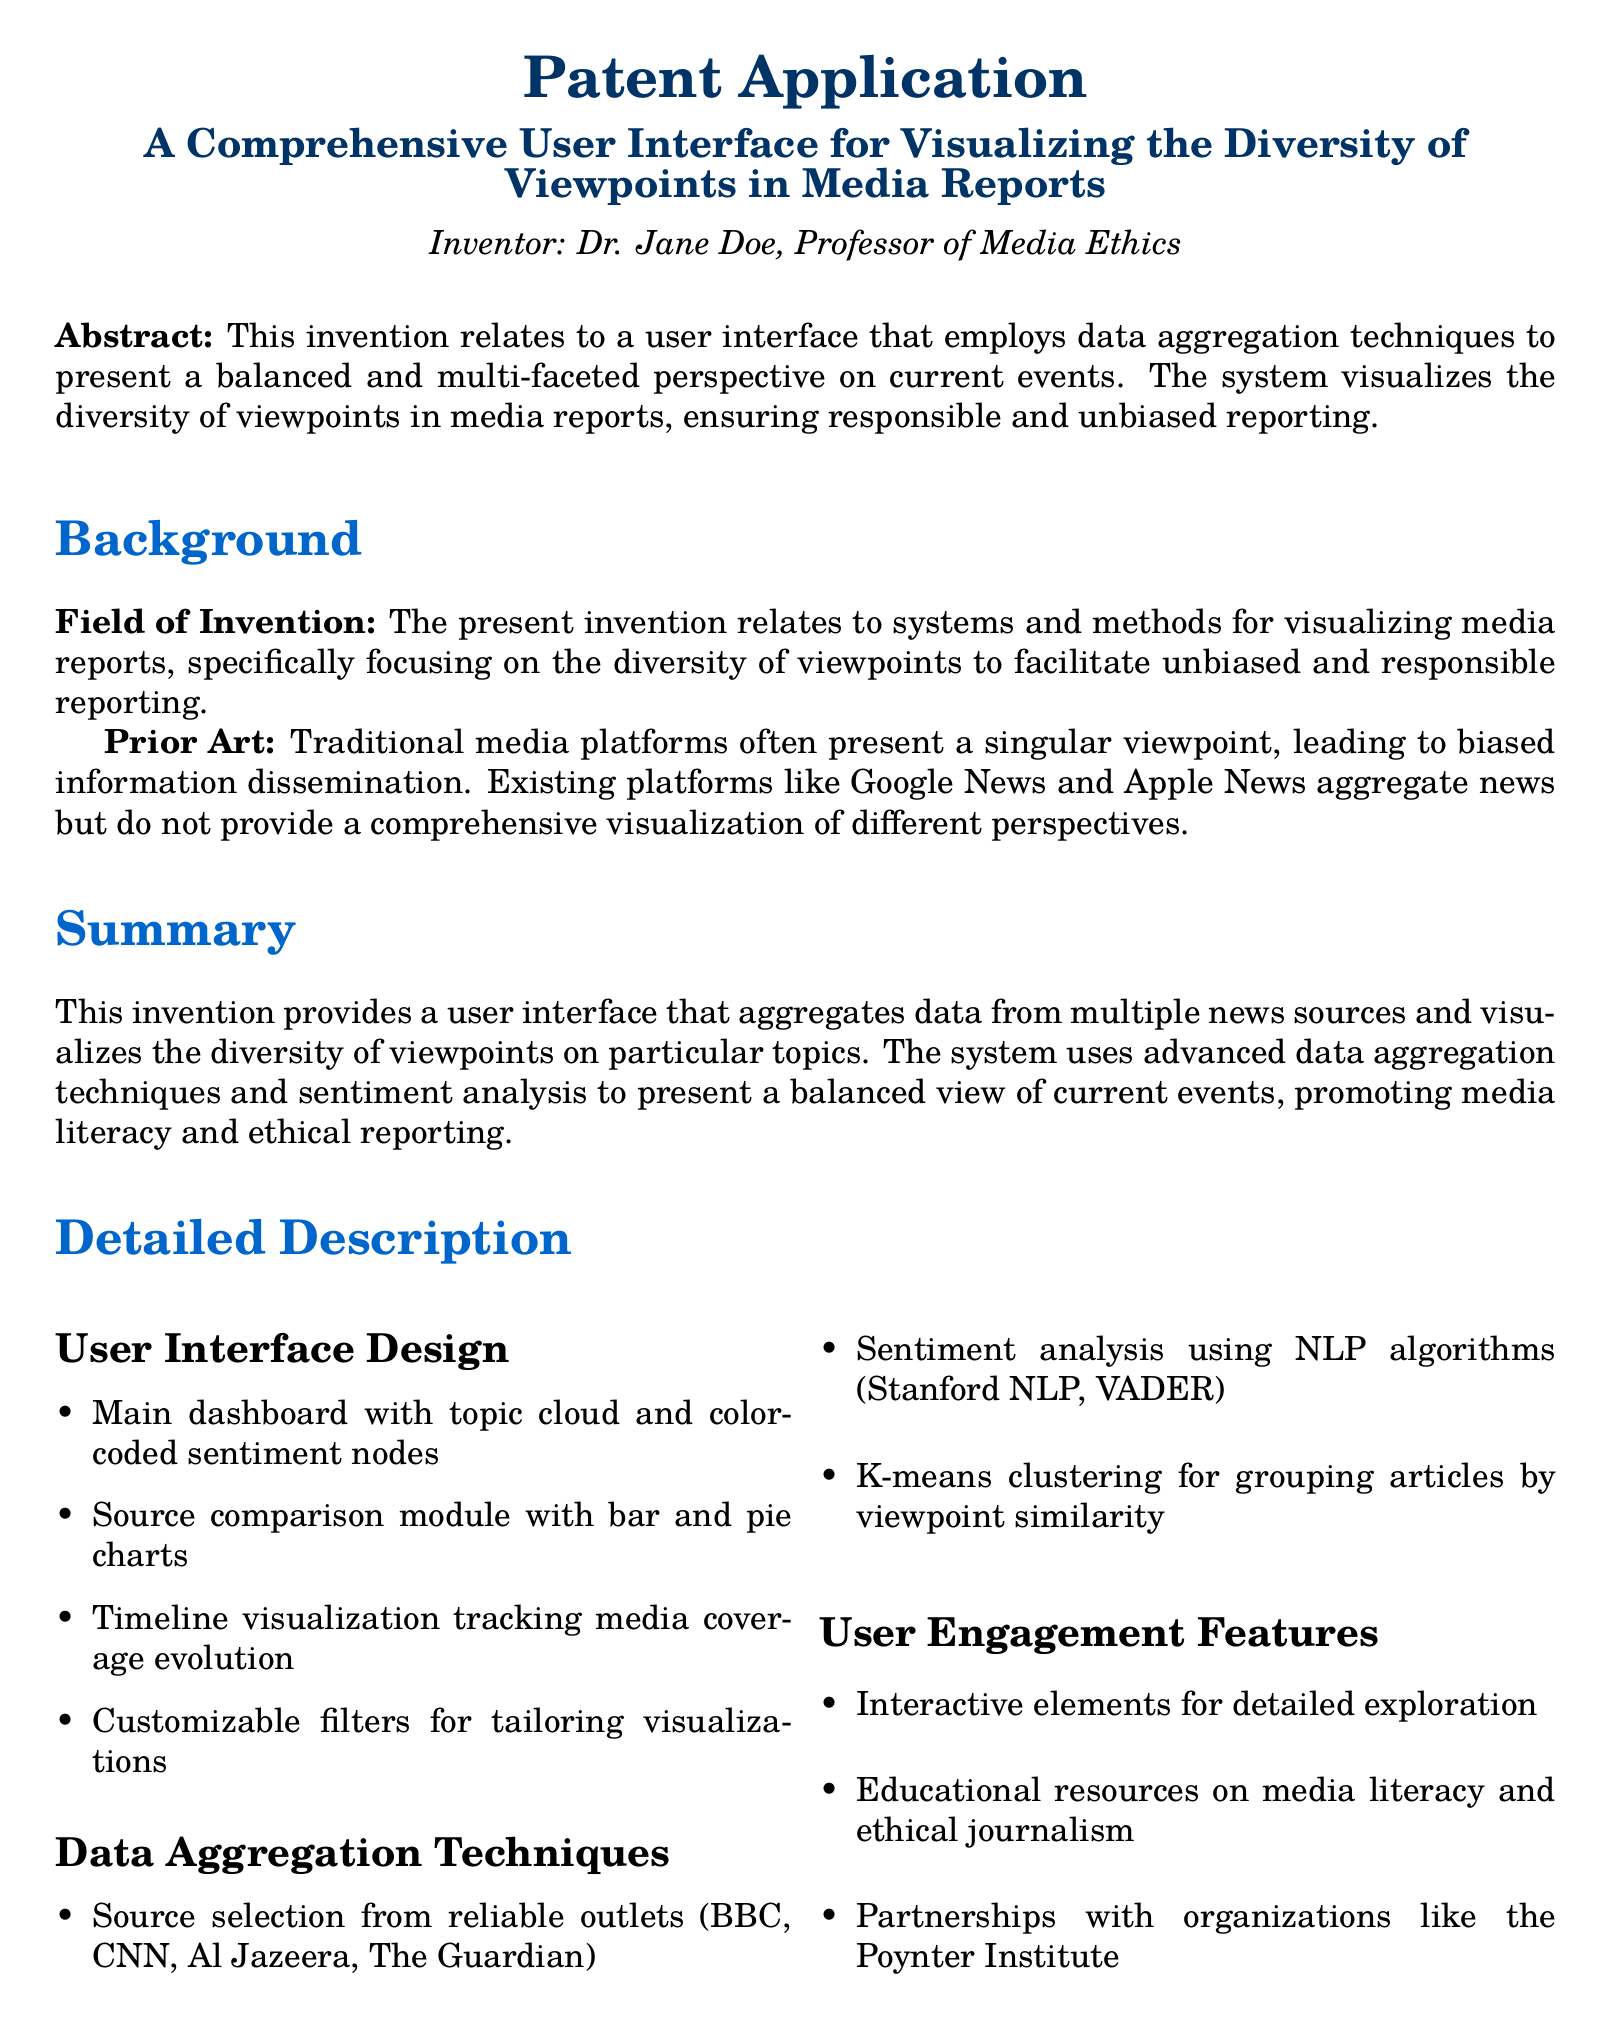What is the title of the patent application? The title is explicitly mentioned in the document under the heading.
Answer: A Comprehensive User Interface for Visualizing the Diversity of Viewpoints in Media Reports Who is the inventor of the user interface? The document attributes the invention to a specific individual in the author section.
Answer: Dr. Jane Doe What is the primary field of invention? The field of invention is identified in the background section of the document.
Answer: Visualizing media reports Which organizations are mentioned as potential partners? The partnerships are listed in the user engagement features section.
Answer: Poynter Institute What technique is used for sentiment analysis in this interface? The document specifies the tools employed for sentiment analysis in the data aggregation section.
Answer: NLP algorithms How many claims are listed in the patent application? The total number of claims is stated in the claims section of the document.
Answer: Three What kind of charts are included in the comparison module? The specific types of visual representations mentioned are found in the user interface design.
Answer: Bar and pie charts What data aggregation technique is used for grouping articles? The document specifies a particular clustering method utilized in the data aggregation section.
Answer: K-means clustering What does the main dashboard feature? Information about the dashboard's contents is found under the user interface design section.
Answer: Topic cloud and color-coded sentiment nodes 